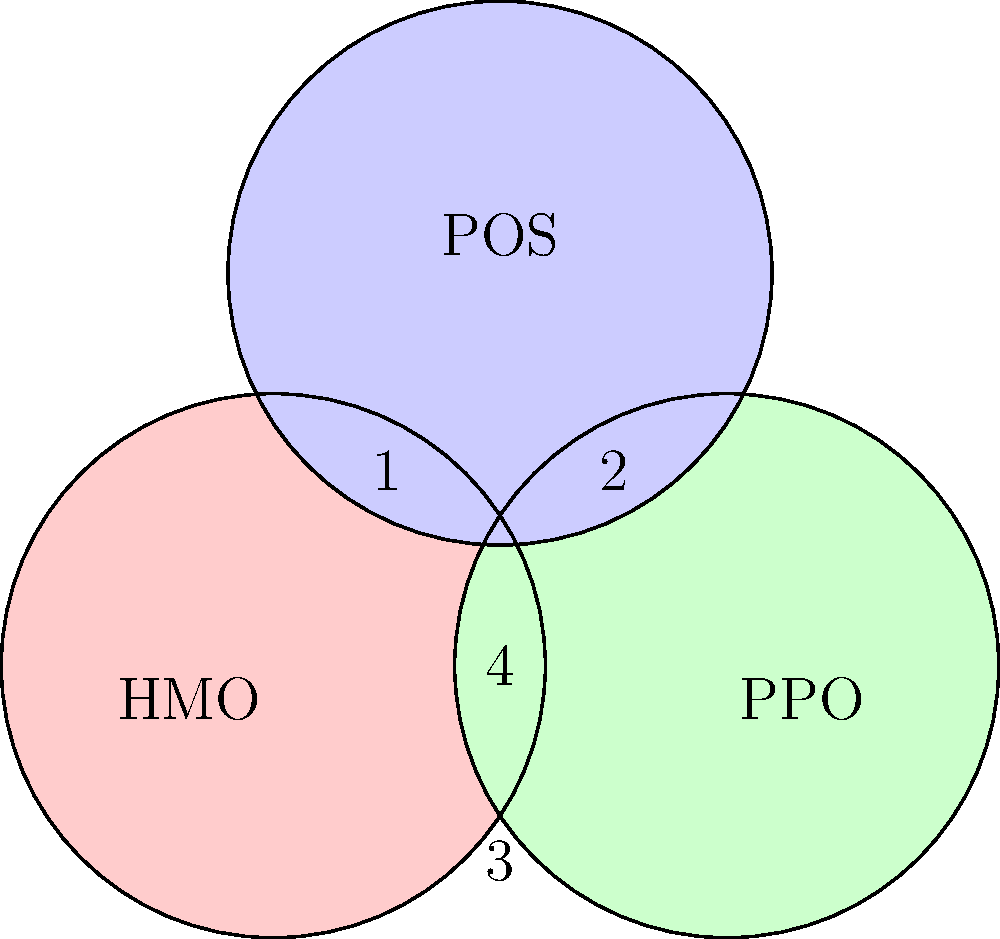In the Venn diagram above, three common types of health insurance plans are represented: Health Maintenance Organization (HMO), Preferred Provider Organization (PPO), and Point of Service (POS). Which region represents plans that combine features of both HMO and PPO, but are not considered POS plans? To answer this question, we need to analyze the Venn diagram and understand the relationships between the different types of health insurance plans:

1. The circle labeled "HMO" represents Health Maintenance Organization plans.
2. The circle labeled "PPO" represents Preferred Provider Organization plans.
3. The circle labeled "POS" represents Point of Service plans.
4. The overlapping regions represent plans that share features of multiple types.

Let's examine each region:

1. Region 1: This area is exclusive to HMO plans.
2. Region 2: This area is exclusive to PPO plans.
3. Region 3: This area is exclusive to POS plans.
4. The region where all three circles overlap (labeled "4"): This represents plans that have features of all three types.

The question asks for plans that combine features of both HMO and PPO but are not considered POS plans. This would be the region where HMO and PPO circles overlap, but does not include the POS circle.

This region is not explicitly labeled in the diagram, but it can be described as the area where HMO and PPO circles intersect, excluding the central region where all three circles overlap.
Answer: The unlabeled region where HMO and PPO circles intersect, excluding the central overlap of all three circles. 